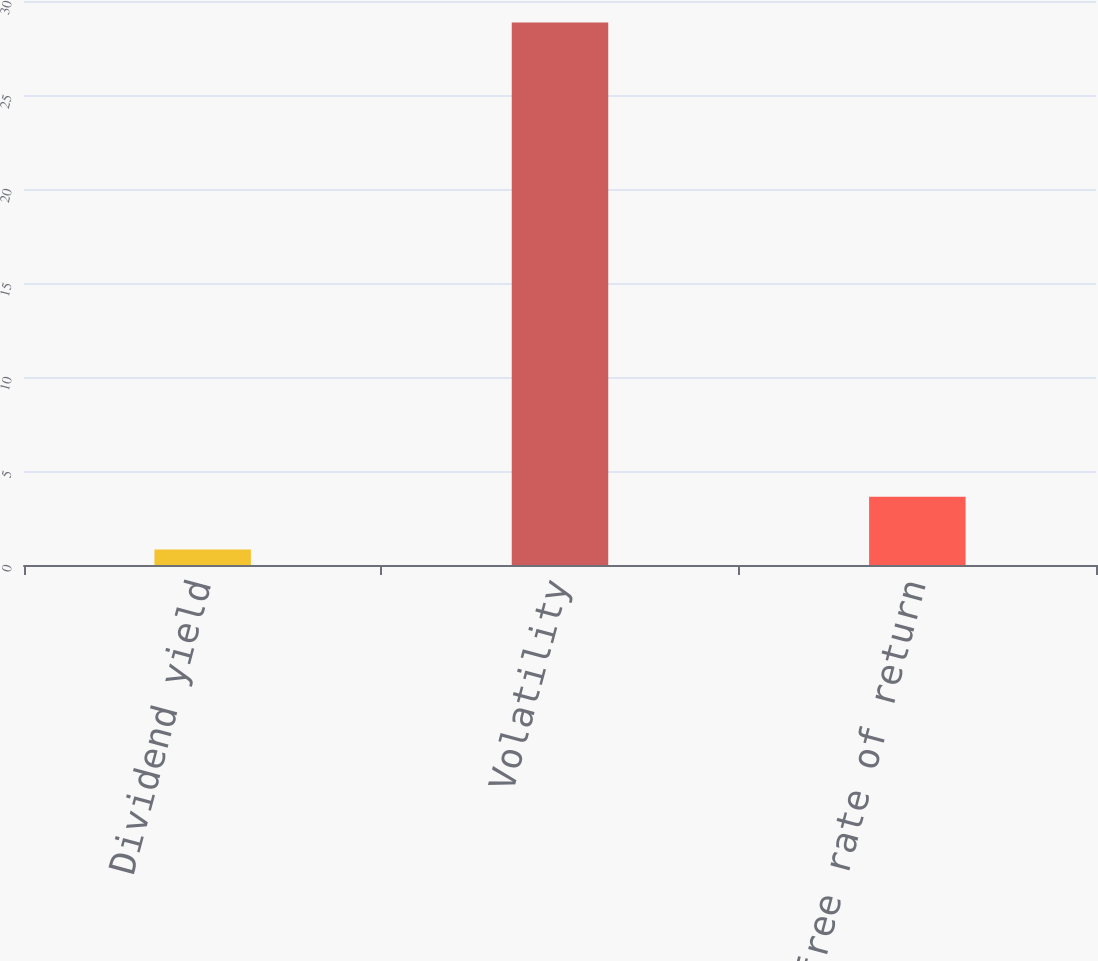Convert chart to OTSL. <chart><loc_0><loc_0><loc_500><loc_500><bar_chart><fcel>Dividend yield<fcel>Volatility<fcel>Risk-free rate of return<nl><fcel>0.83<fcel>28.85<fcel>3.63<nl></chart> 